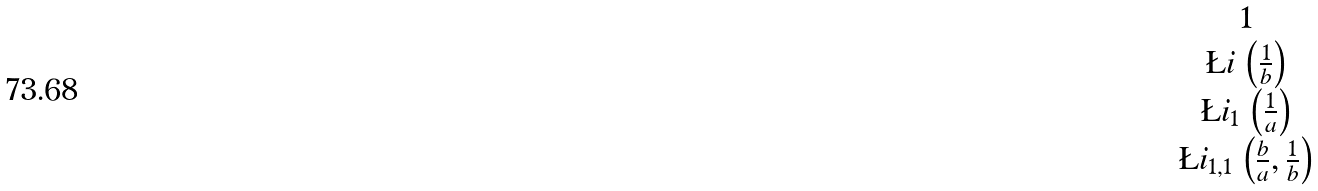<formula> <loc_0><loc_0><loc_500><loc_500>\begin{matrix} 1 \\ \L i \, \left ( \frac { 1 } { b } \right ) \\ \L i _ { 1 } \, \left ( \frac { 1 } { a } \right ) \\ \L i _ { 1 , 1 } \, \left ( \frac { b } { a } , \frac { 1 } { b } \right ) \end{matrix}</formula> 